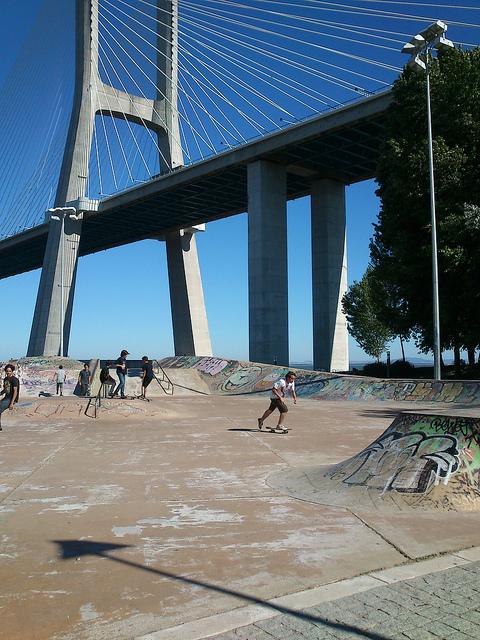What is the name of the bridge?
Short answer required. Golden gate. Is this a vacation resort?
Quick response, please. No. Which side of the picture is the light source coming from?
Quick response, please. Right. Is there a bridge in the picture?
Quick response, please. Yes. 